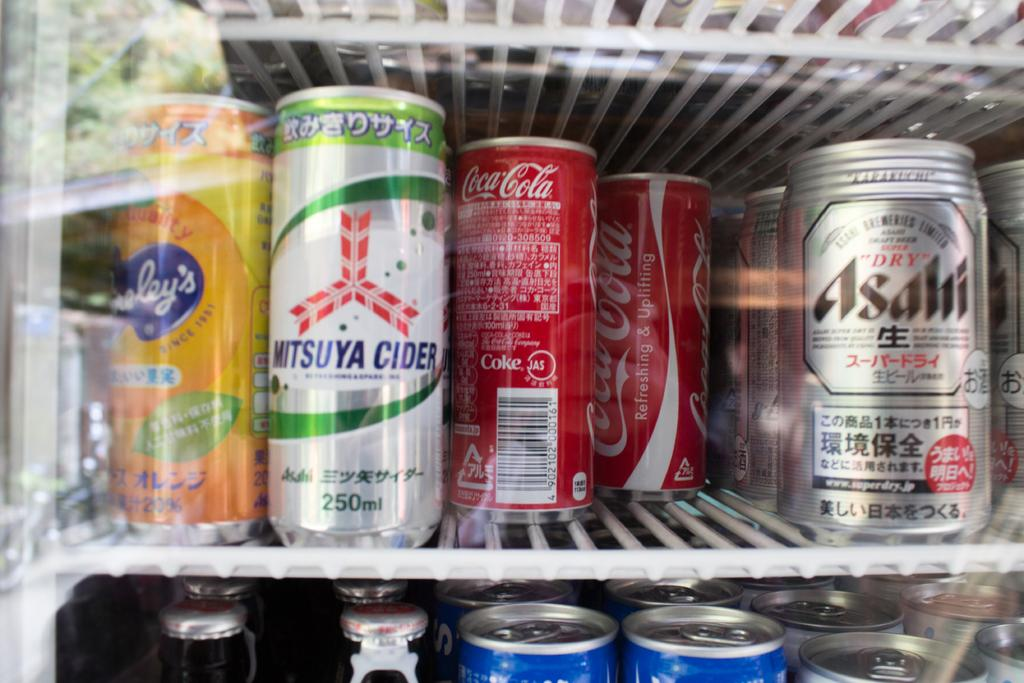What type of containers are visible in the image? There are beverage cans in the image. Where are the beverage cans located? The beverage cans are placed in a refrigerator. What type of pizzas can be seen in the image? There are no pizzas present in the image; it only features beverage cans in a refrigerator. 